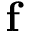Convert formula to latex. <formula><loc_0><loc_0><loc_500><loc_500>f</formula> 